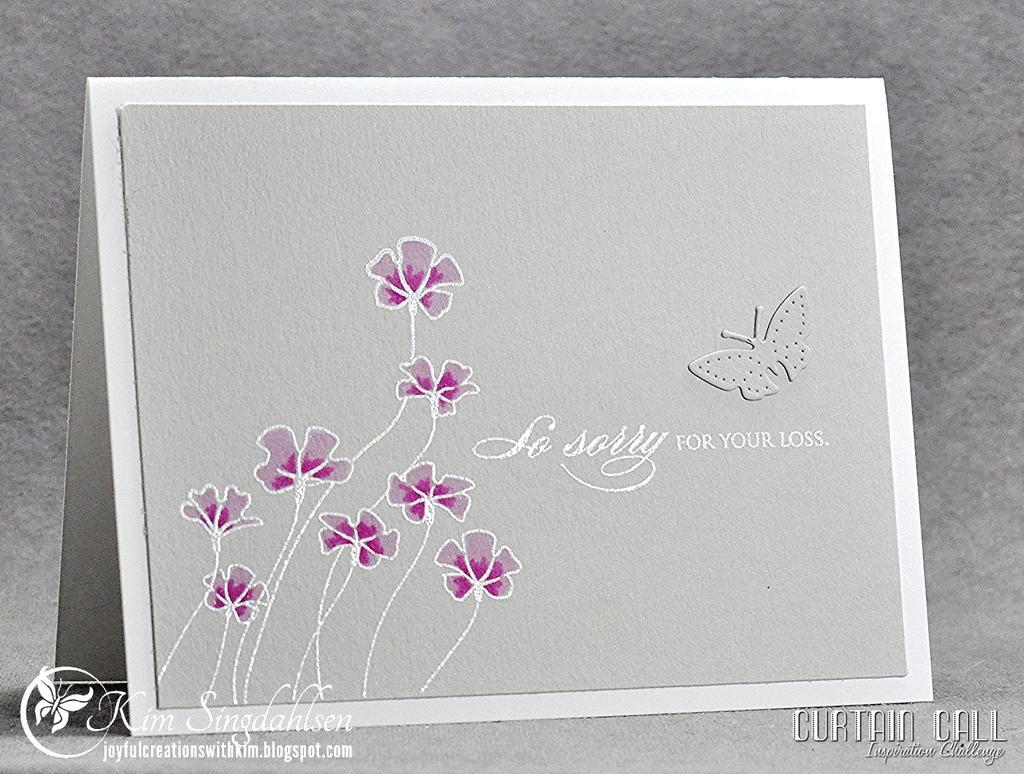Can you describe this image briefly? In this picture, we can see a poster with some text, and images on it, we can see some watermarks on the bottom left and bottom right side of the picture. 